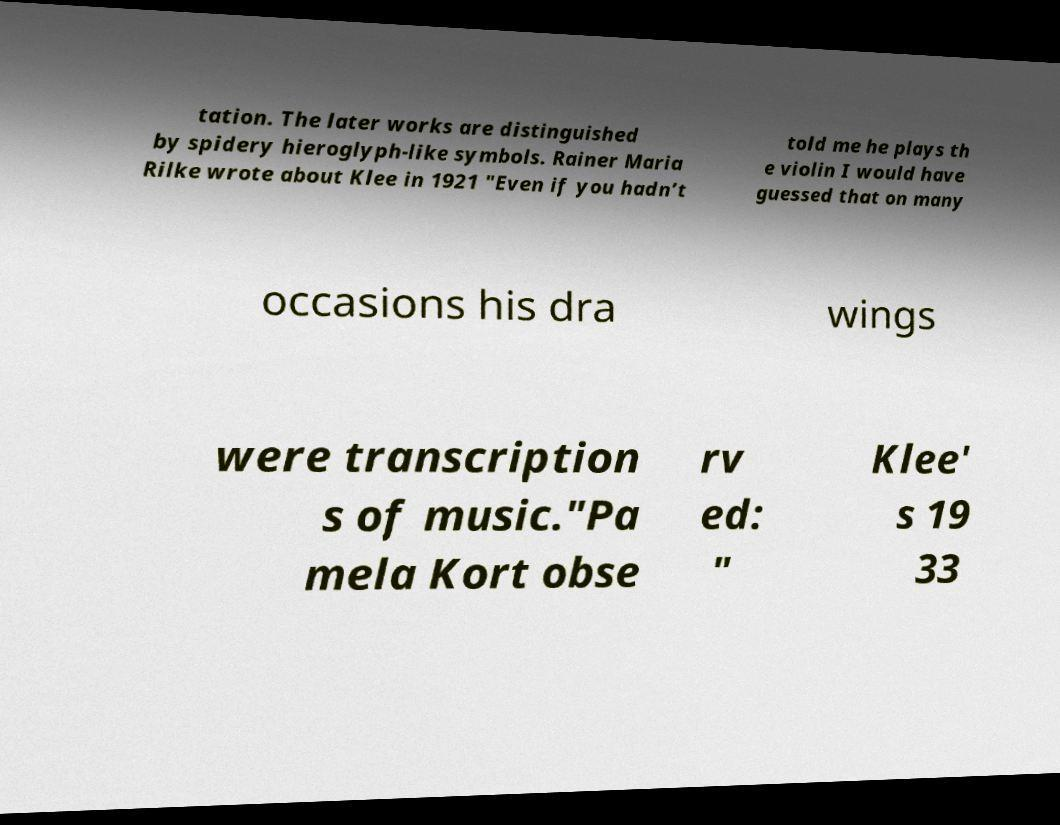Could you assist in decoding the text presented in this image and type it out clearly? tation. The later works are distinguished by spidery hieroglyph-like symbols. Rainer Maria Rilke wrote about Klee in 1921 "Even if you hadn’t told me he plays th e violin I would have guessed that on many occasions his dra wings were transcription s of music."Pa mela Kort obse rv ed: " Klee' s 19 33 